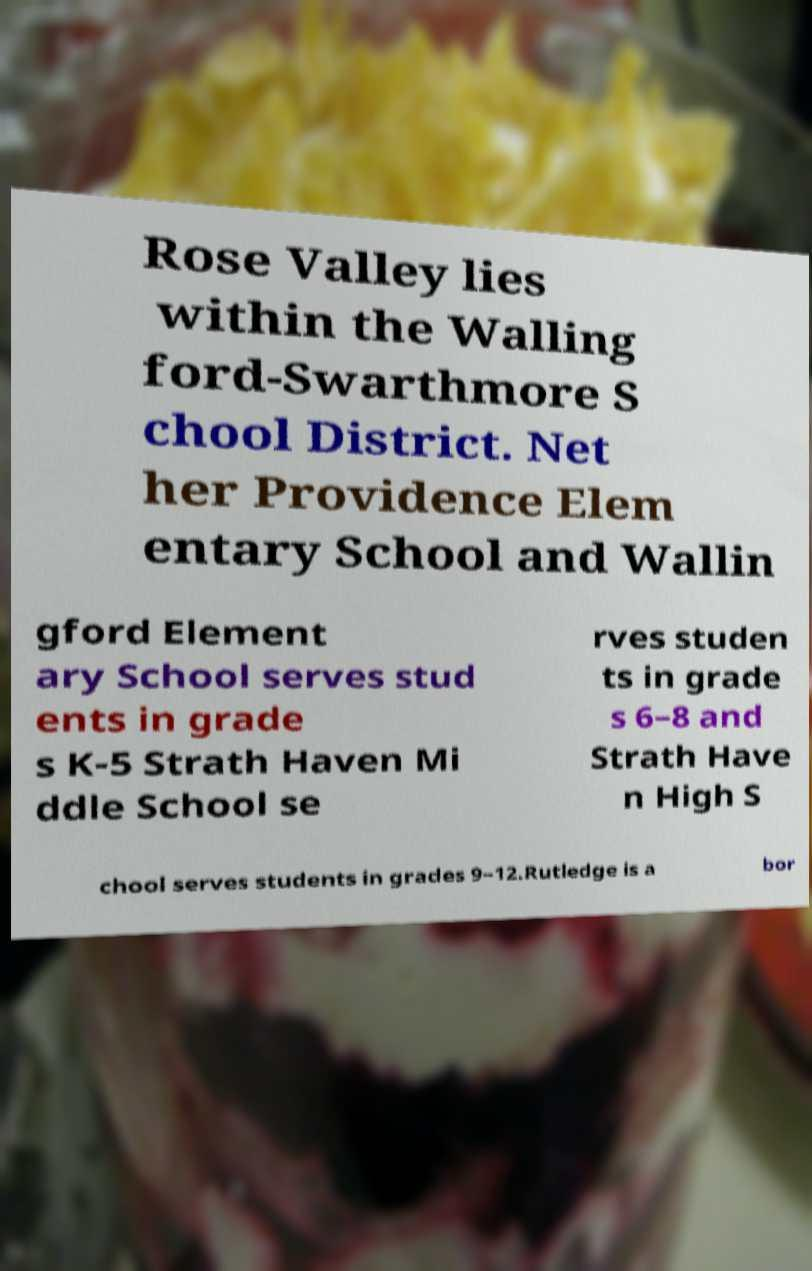For documentation purposes, I need the text within this image transcribed. Could you provide that? Rose Valley lies within the Walling ford-Swarthmore S chool District. Net her Providence Elem entary School and Wallin gford Element ary School serves stud ents in grade s K-5 Strath Haven Mi ddle School se rves studen ts in grade s 6–8 and Strath Have n High S chool serves students in grades 9–12.Rutledge is a bor 